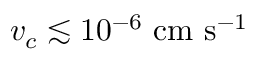<formula> <loc_0><loc_0><loc_500><loc_500>v _ { c } \lesssim 1 0 ^ { - 6 } \ c m \ s ^ { - 1 }</formula> 